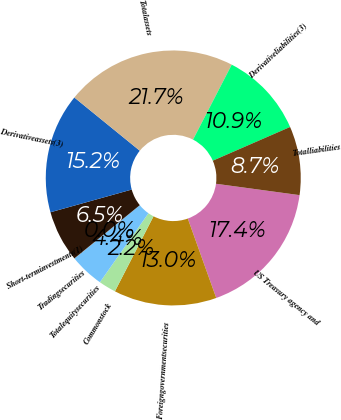<chart> <loc_0><loc_0><loc_500><loc_500><pie_chart><fcel>US Treasury agency and<fcel>Foreigngovernmentsecurities<fcel>Commonstock<fcel>Totalequitysecurities<fcel>Tradingsecurities<fcel>Short-terminvestments(1)<fcel>Derivativeassets(3)<fcel>Totalassets<fcel>Derivativeliabilities(3)<fcel>Totalliabilities<nl><fcel>17.38%<fcel>13.04%<fcel>2.19%<fcel>4.36%<fcel>0.02%<fcel>6.53%<fcel>15.21%<fcel>21.72%<fcel>10.87%<fcel>8.7%<nl></chart> 